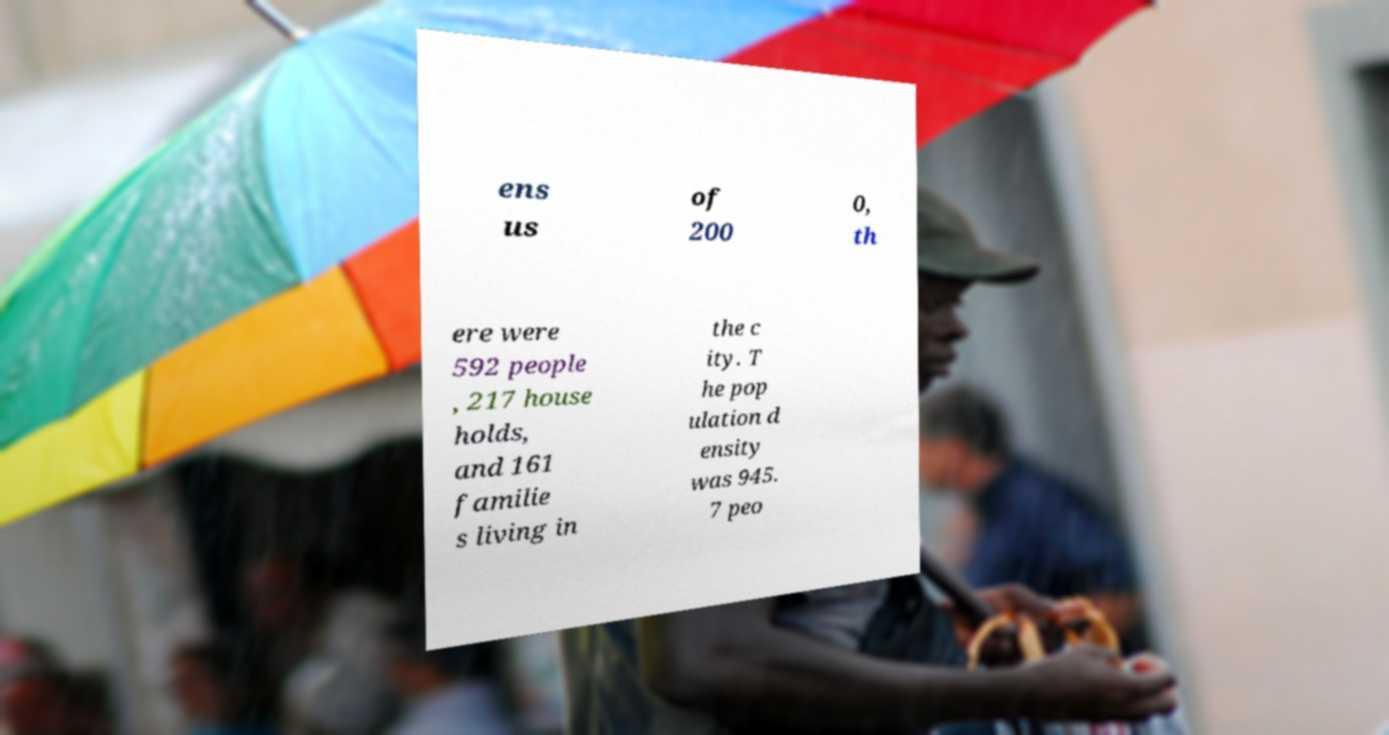Please read and relay the text visible in this image. What does it say? ens us of 200 0, th ere were 592 people , 217 house holds, and 161 familie s living in the c ity. T he pop ulation d ensity was 945. 7 peo 